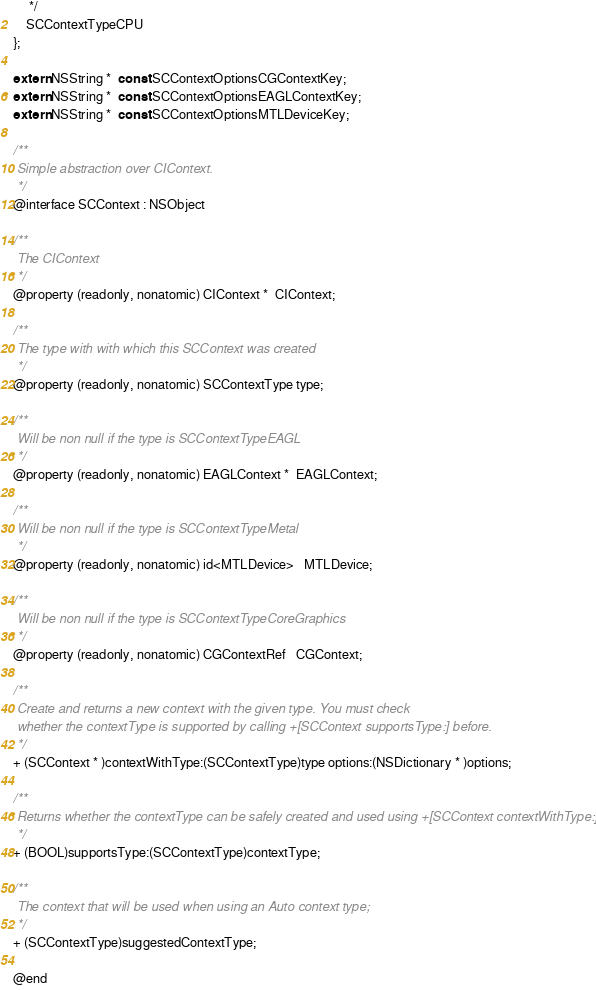Convert code to text. <code><loc_0><loc_0><loc_500><loc_500><_C_>     */
    SCContextTypeCPU
};

extern NSString *  const SCContextOptionsCGContextKey;
extern NSString *  const SCContextOptionsEAGLContextKey;
extern NSString *  const SCContextOptionsMTLDeviceKey;

/**
 Simple abstraction over CIContext.
 */
@interface SCContext : NSObject

/**
 The CIContext
 */
@property (readonly, nonatomic) CIContext *  CIContext;

/**
 The type with with which this SCContext was created
 */
@property (readonly, nonatomic) SCContextType type;

/**
 Will be non null if the type is SCContextTypeEAGL
 */
@property (readonly, nonatomic) EAGLContext *  EAGLContext;

/**
 Will be non null if the type is SCContextTypeMetal
 */
@property (readonly, nonatomic) id<MTLDevice>   MTLDevice;

/**
 Will be non null if the type is SCContextTypeCoreGraphics
 */
@property (readonly, nonatomic) CGContextRef   CGContext;

/**
 Create and returns a new context with the given type. You must check
 whether the contextType is supported by calling +[SCContext supportsType:] before.
 */
+ (SCContext * )contextWithType:(SCContextType)type options:(NSDictionary * )options;

/**
 Returns whether the contextType can be safely created and used using +[SCContext contextWithType:]
 */
+ (BOOL)supportsType:(SCContextType)contextType;

/**
 The context that will be used when using an Auto context type;
 */
+ (SCContextType)suggestedContextType;

@end
</code> 